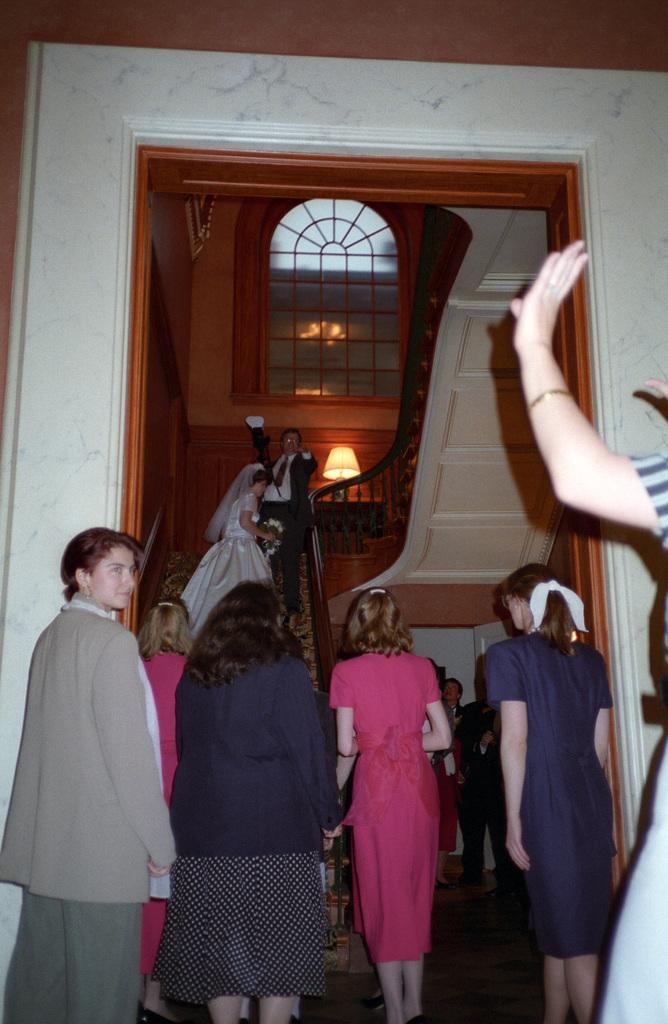Could you give a brief overview of what you see in this image? In this picture I can see the girl who is wearing white dress and holding a flowers, she is standing on the stairs. Beside her there is a man who is wearing suit, trouser and shoes. At the bottom I can see many people were standing near to the stairs and door frame. At the top there is a window. On the right I can see the woman who is standing near to the wall. 